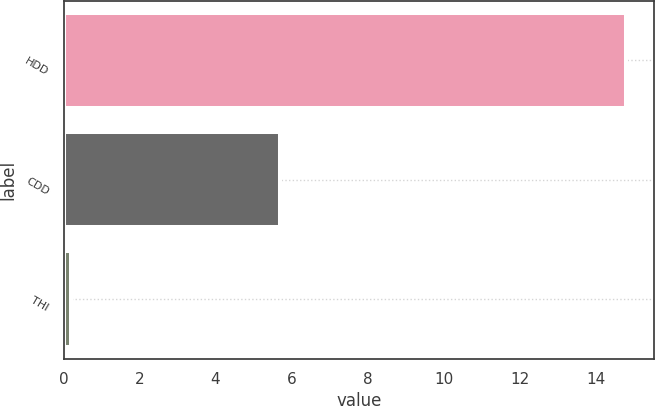<chart> <loc_0><loc_0><loc_500><loc_500><bar_chart><fcel>HDD<fcel>CDD<fcel>THI<nl><fcel>14.8<fcel>5.7<fcel>0.2<nl></chart> 